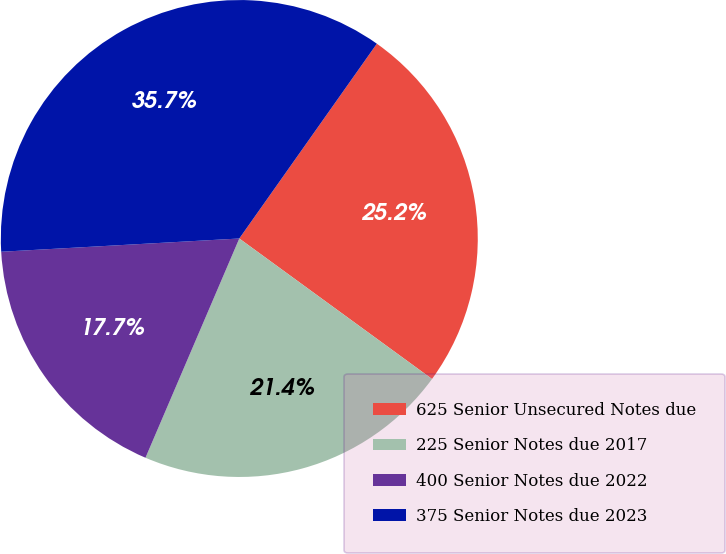<chart> <loc_0><loc_0><loc_500><loc_500><pie_chart><fcel>625 Senior Unsecured Notes due<fcel>225 Senior Notes due 2017<fcel>400 Senior Notes due 2022<fcel>375 Senior Notes due 2023<nl><fcel>25.24%<fcel>21.41%<fcel>17.68%<fcel>35.67%<nl></chart> 